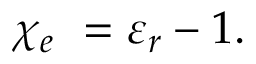Convert formula to latex. <formula><loc_0><loc_0><loc_500><loc_500>\chi _ { e } \ = \varepsilon _ { r } - 1 .</formula> 